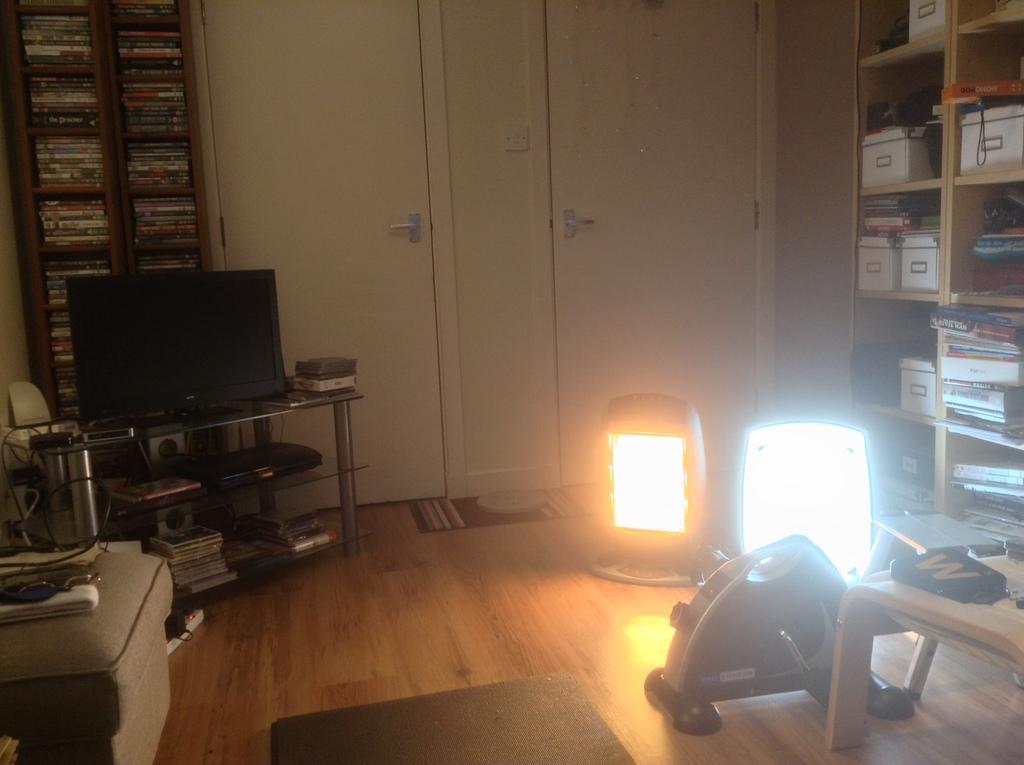Can you describe this image briefly? This image is clicked in a room. In the front, we can see a table on which there is a TV along with speakers. In the background, there are cupboards and doors. And many books are kept in that cupboard. On the right, there is a rack in which many boxes are kept. At the bottom, there is a floor. In the front, we can see two lights. On the left, there is a couch. 